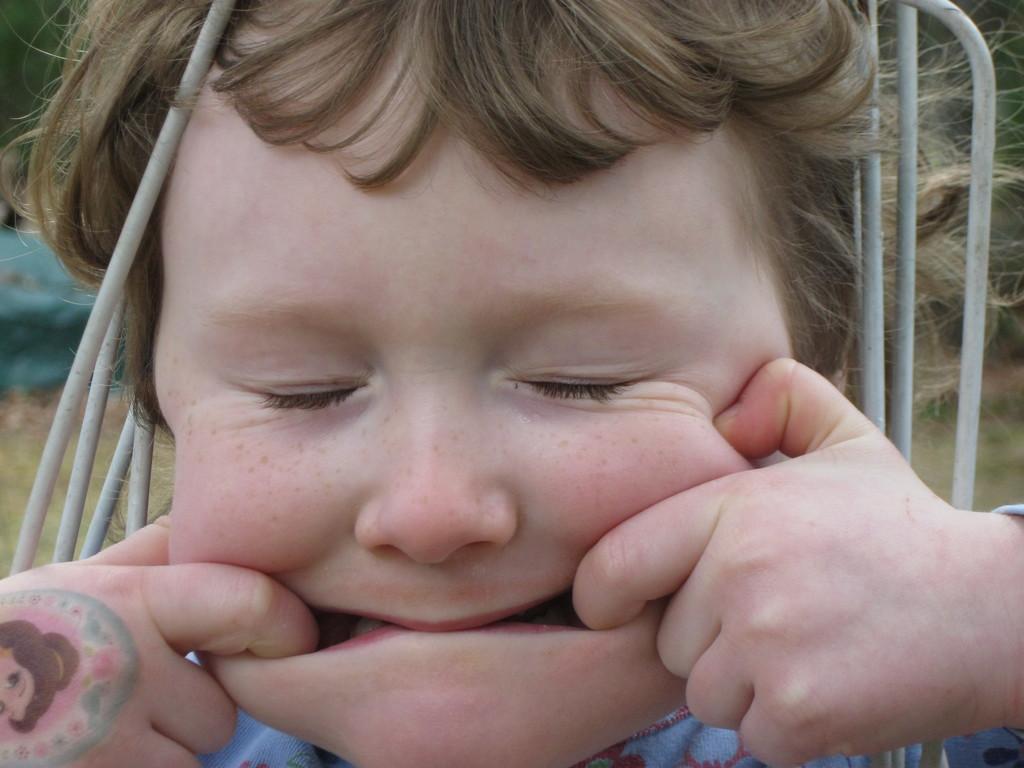Describe this image in one or two sentences. In this image in the foreground there is one boy, and there are some small pipes and there is a blurry background. 